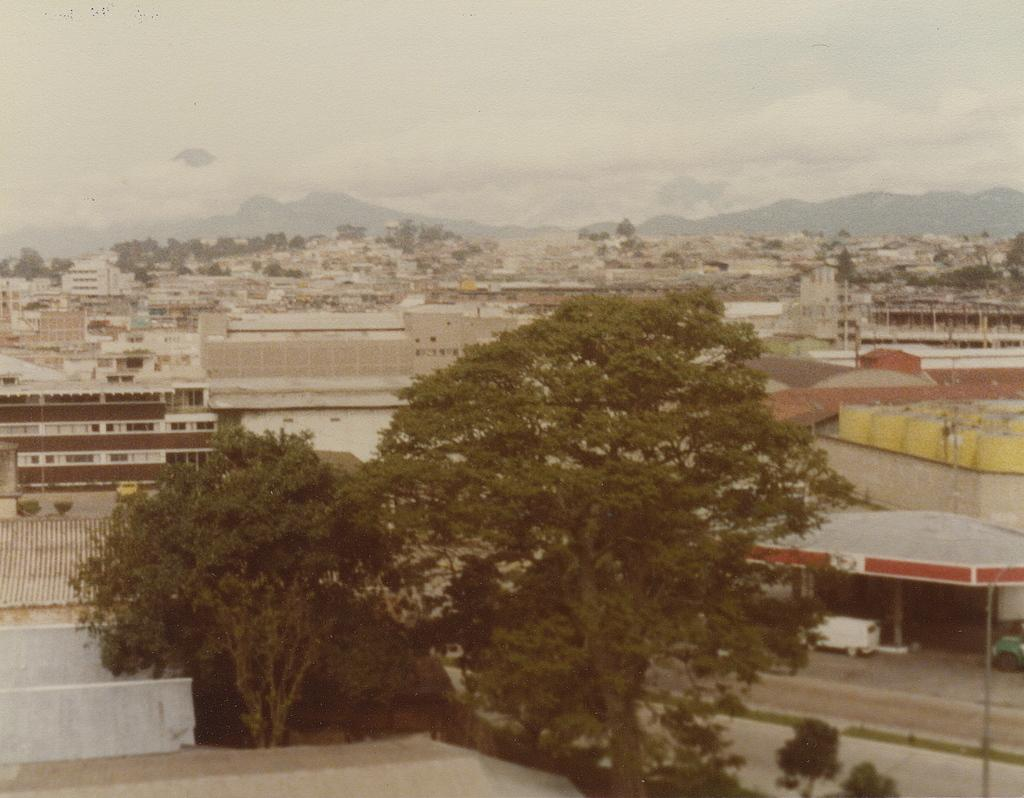What type of natural elements can be seen in the image? There are trees in the image. What type of vehicle is present in the image? There is a truck in the image. What type of man-made structures can be seen in the image? There are buildings in the image. What is visible in the background of the image? The sky is visible in the image. Can you see any gold objects in the image? There is no gold object present in the image. Is there an ocean visible in the image? There is no ocean present in the image. 